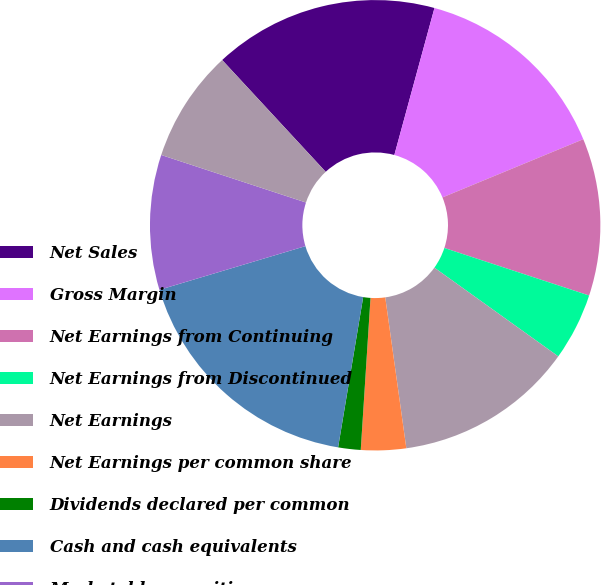Convert chart to OTSL. <chart><loc_0><loc_0><loc_500><loc_500><pie_chart><fcel>Net Sales<fcel>Gross Margin<fcel>Net Earnings from Continuing<fcel>Net Earnings from Discontinued<fcel>Net Earnings<fcel>Net Earnings per common share<fcel>Dividends declared per common<fcel>Cash and cash equivalents<fcel>Marketable securities<fcel>Net Earnings/(Loss) from<nl><fcel>16.13%<fcel>14.52%<fcel>11.29%<fcel>4.84%<fcel>12.9%<fcel>3.23%<fcel>1.61%<fcel>17.74%<fcel>9.68%<fcel>8.06%<nl></chart> 